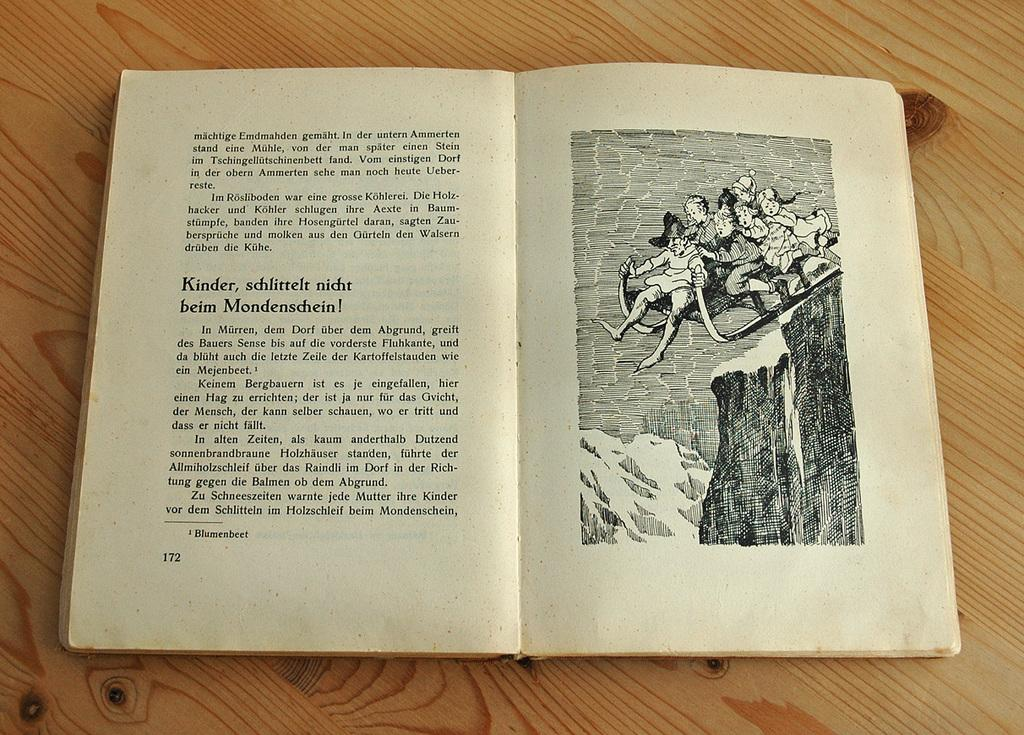<image>
Render a clear and concise summary of the photo. Kinder, schlittle nicht beim Mondenschein! and a photo of the story is opened on page 172. 